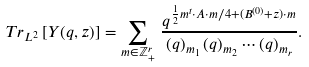<formula> <loc_0><loc_0><loc_500><loc_500>T r _ { L ^ { 2 } } \left [ Y ( q , z ) \right ] = \sum _ { m \in \mathbb { Z } ^ { r } _ { + } } \, \frac { q ^ { \frac { 1 } { 2 } m ^ { t } \cdot A \cdot m / 4 + ( B ^ { ( 0 ) } + z ) \cdot m } } { ( q ) _ { m _ { 1 } } \, ( q ) _ { m _ { 2 } } \cdots ( q ) _ { m _ { r } } } .</formula> 